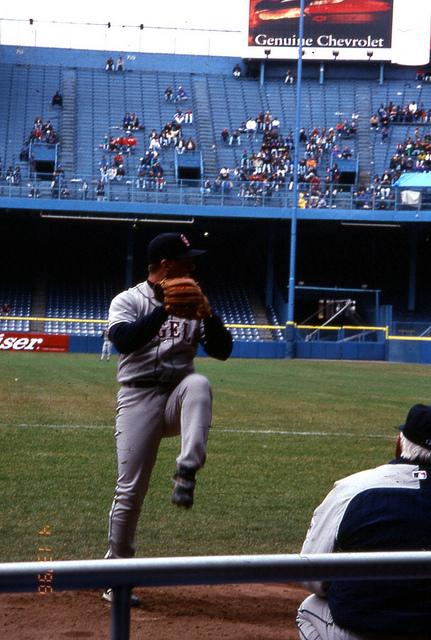What is the man doing?
Be succinct. Pitching. What does the poster on the stands say?
Concise answer only. Genuine chevrolet. What is the color of the poster on the stands?
Give a very brief answer. Red. Has the game started?
Concise answer only. Yes. 